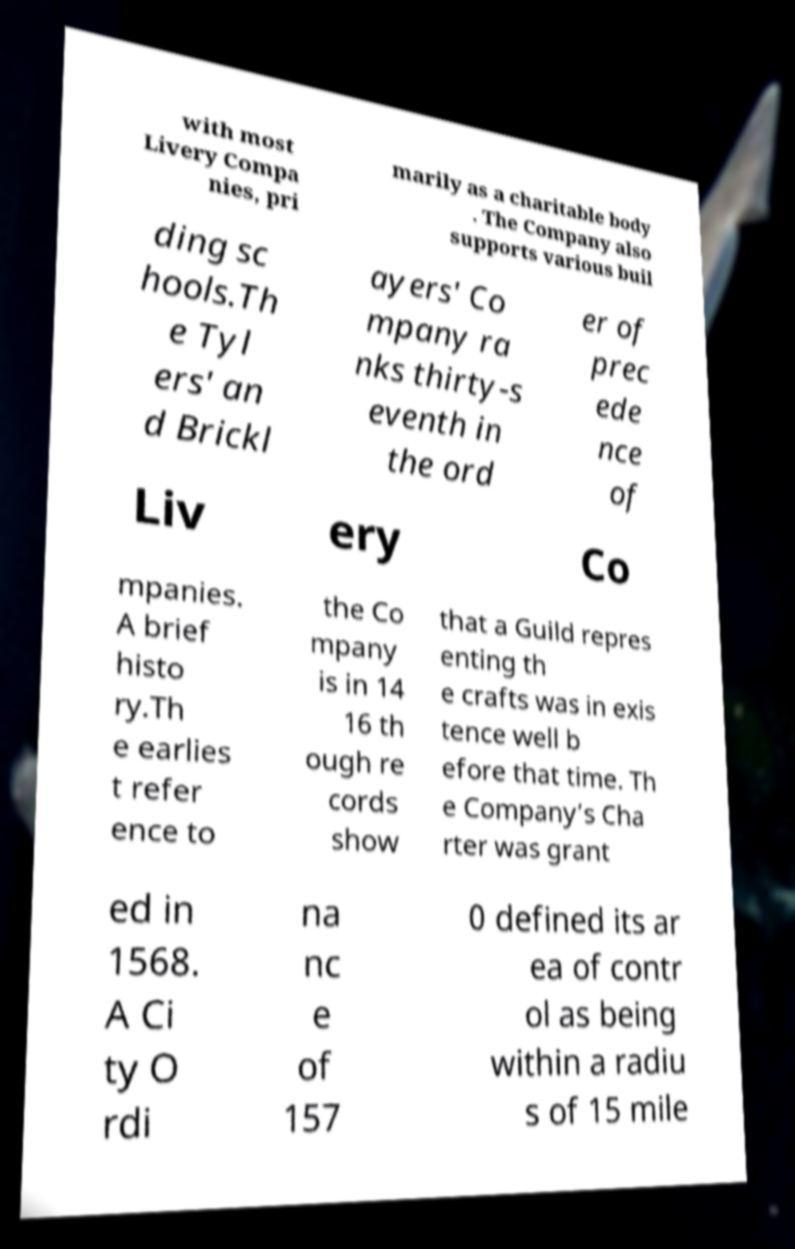For documentation purposes, I need the text within this image transcribed. Could you provide that? with most Livery Compa nies, pri marily as a charitable body . The Company also supports various buil ding sc hools.Th e Tyl ers' an d Brickl ayers' Co mpany ra nks thirty-s eventh in the ord er of prec ede nce of Liv ery Co mpanies. A brief histo ry.Th e earlies t refer ence to the Co mpany is in 14 16 th ough re cords show that a Guild repres enting th e crafts was in exis tence well b efore that time. Th e Company’s Cha rter was grant ed in 1568. A Ci ty O rdi na nc e of 157 0 defined its ar ea of contr ol as being within a radiu s of 15 mile 